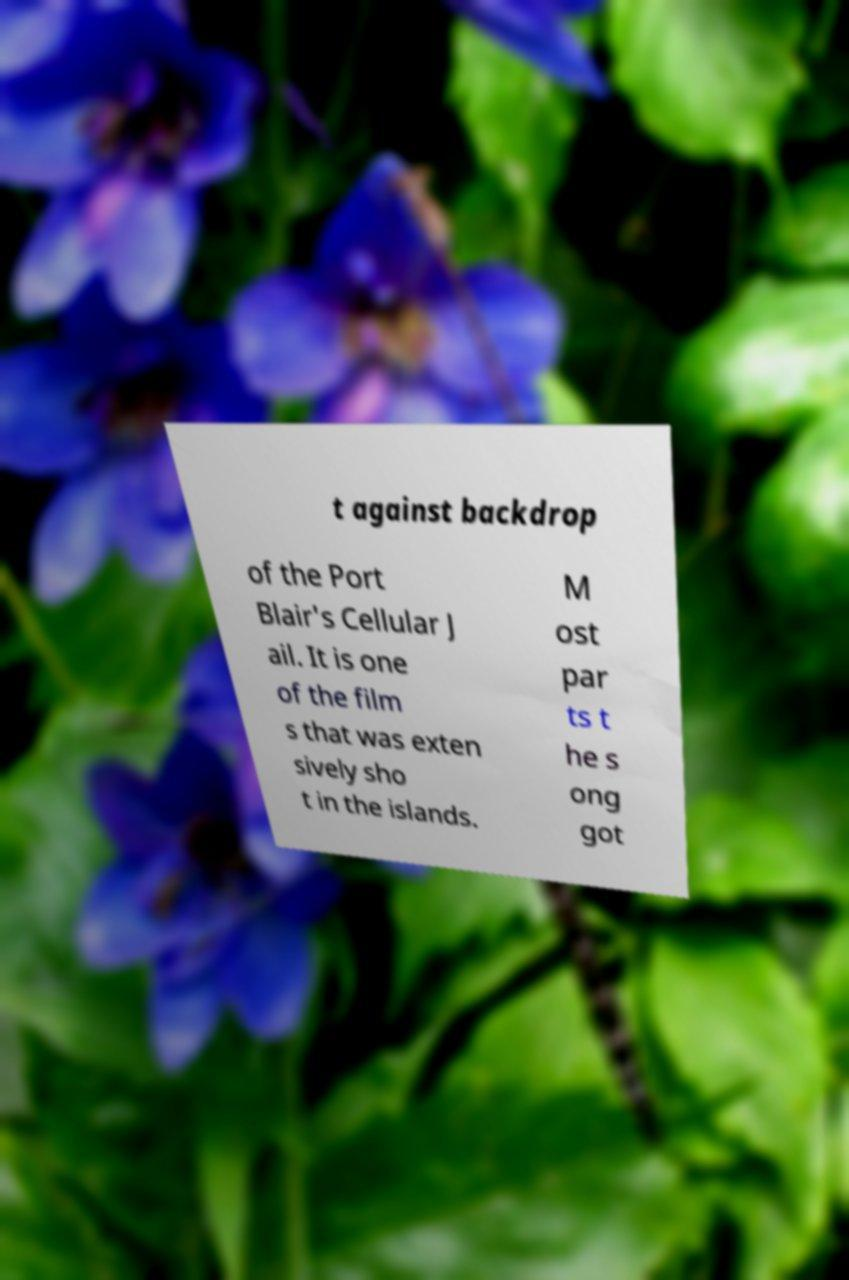Can you accurately transcribe the text from the provided image for me? t against backdrop of the Port Blair's Cellular J ail. It is one of the film s that was exten sively sho t in the islands. M ost par ts t he s ong got 